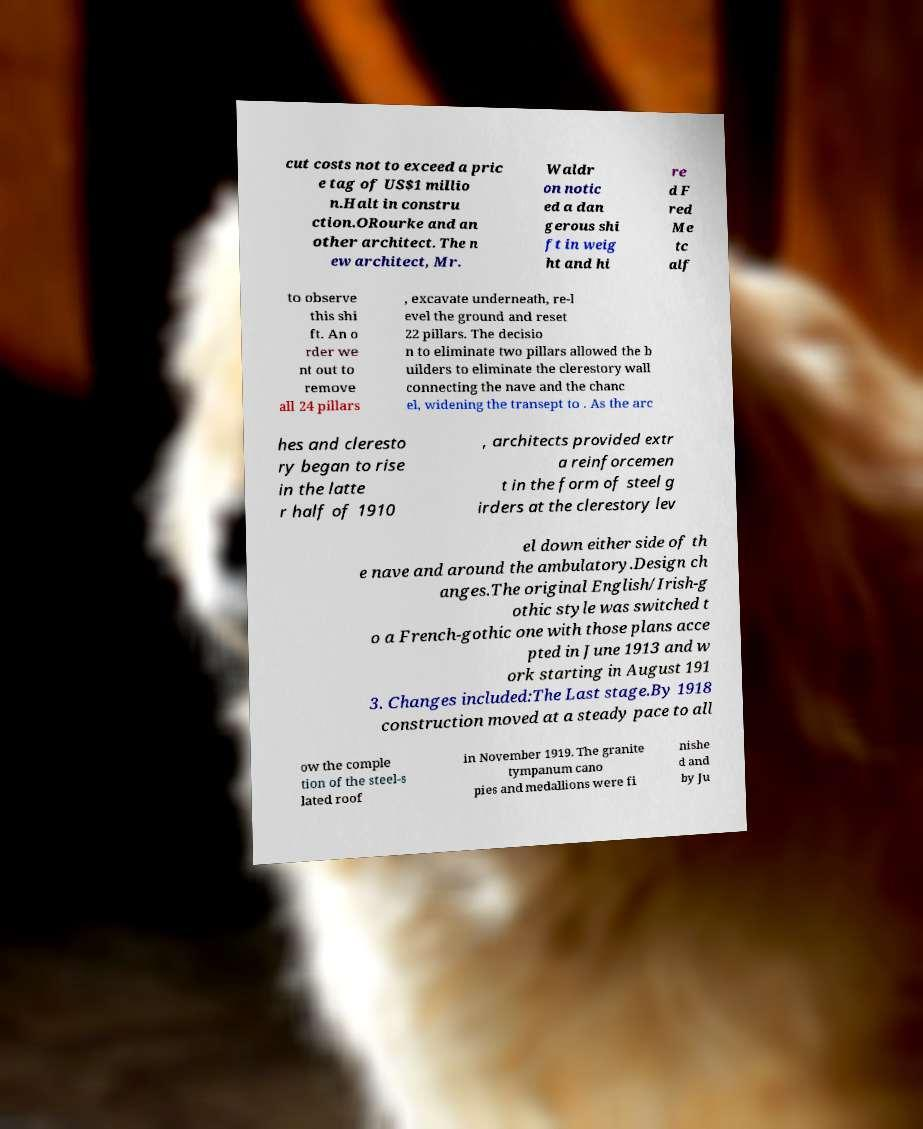There's text embedded in this image that I need extracted. Can you transcribe it verbatim? cut costs not to exceed a pric e tag of US$1 millio n.Halt in constru ction.ORourke and an other architect. The n ew architect, Mr. Waldr on notic ed a dan gerous shi ft in weig ht and hi re d F red Me tc alf to observe this shi ft. An o rder we nt out to remove all 24 pillars , excavate underneath, re-l evel the ground and reset 22 pillars. The decisio n to eliminate two pillars allowed the b uilders to eliminate the clerestory wall connecting the nave and the chanc el, widening the transept to . As the arc hes and cleresto ry began to rise in the latte r half of 1910 , architects provided extr a reinforcemen t in the form of steel g irders at the clerestory lev el down either side of th e nave and around the ambulatory.Design ch anges.The original English/Irish-g othic style was switched t o a French-gothic one with those plans acce pted in June 1913 and w ork starting in August 191 3. Changes included:The Last stage.By 1918 construction moved at a steady pace to all ow the comple tion of the steel-s lated roof in November 1919. The granite tympanum cano pies and medallions were fi nishe d and by Ju 